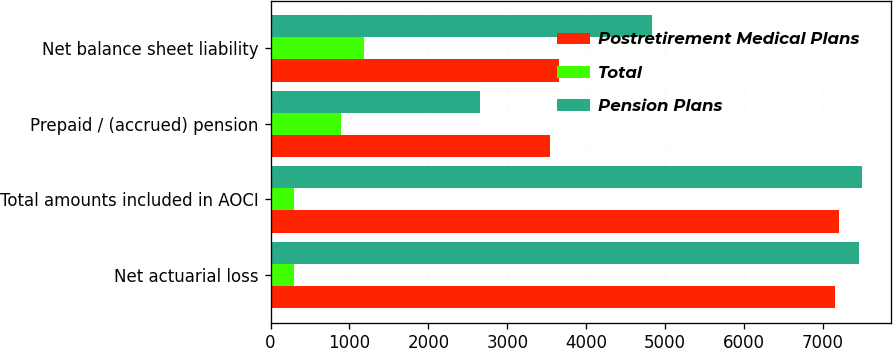Convert chart. <chart><loc_0><loc_0><loc_500><loc_500><stacked_bar_chart><ecel><fcel>Net actuarial loss<fcel>Total amounts included in AOCI<fcel>Prepaid / (accrued) pension<fcel>Net balance sheet liability<nl><fcel>Postretirement Medical Plans<fcel>7156<fcel>7197<fcel>3544<fcel>3653<nl><fcel>Total<fcel>294<fcel>294<fcel>890<fcel>1184<nl><fcel>Pension Plans<fcel>7450<fcel>7491<fcel>2654<fcel>4837<nl></chart> 